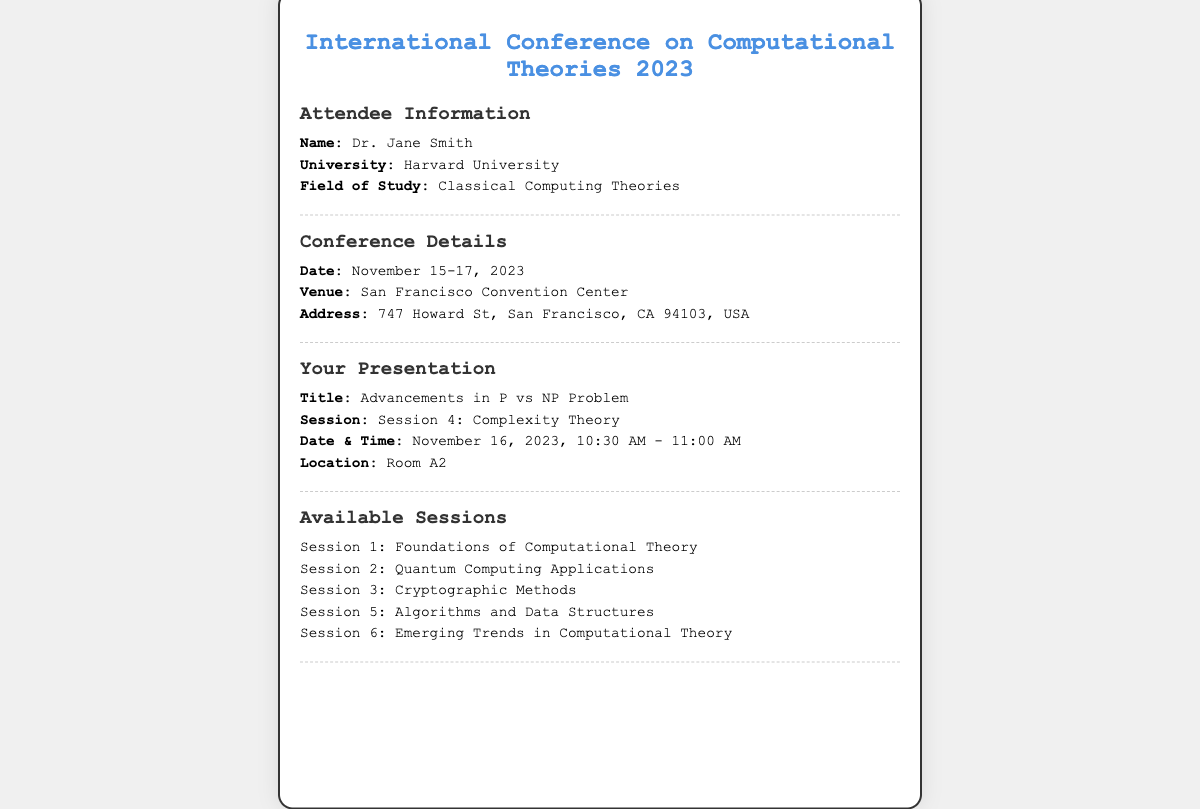what is the conference title? The title of the conference is prominently displayed at the top of the ticket.
Answer: International Conference on Computational Theories 2023 who is the attendee? The attendee's name is clearly mentioned in the attendee information section.
Answer: Dr. Jane Smith what is the date of the conference? The date is specified in the conference details section.
Answer: November 15-17, 2023 what is the location of Dr. Smith's presentation? The location is specified in the presentation section of the ticket.
Answer: Room A2 what session will Dr. Smith present in? The session is mentioned under the presentation details.
Answer: Session 4: Complexity Theory what is the address of the conference venue? The complete address is provided under the conference details section.
Answer: 747 Howard St, San Francisco, CA 94103, USA how long is Dr. Smith's presentation? The duration can be inferred from the start and end times given in the presentation details.
Answer: 30 minutes which session focuses on Quantum Computing? The sessions are listed, and this one is among them.
Answer: Session 2: Quantum Computing Applications what time is Dr. Smith's presentation scheduled? The exact time is noted in the presentation details section.
Answer: November 16, 2023, 10:30 AM - 11:00 AM 